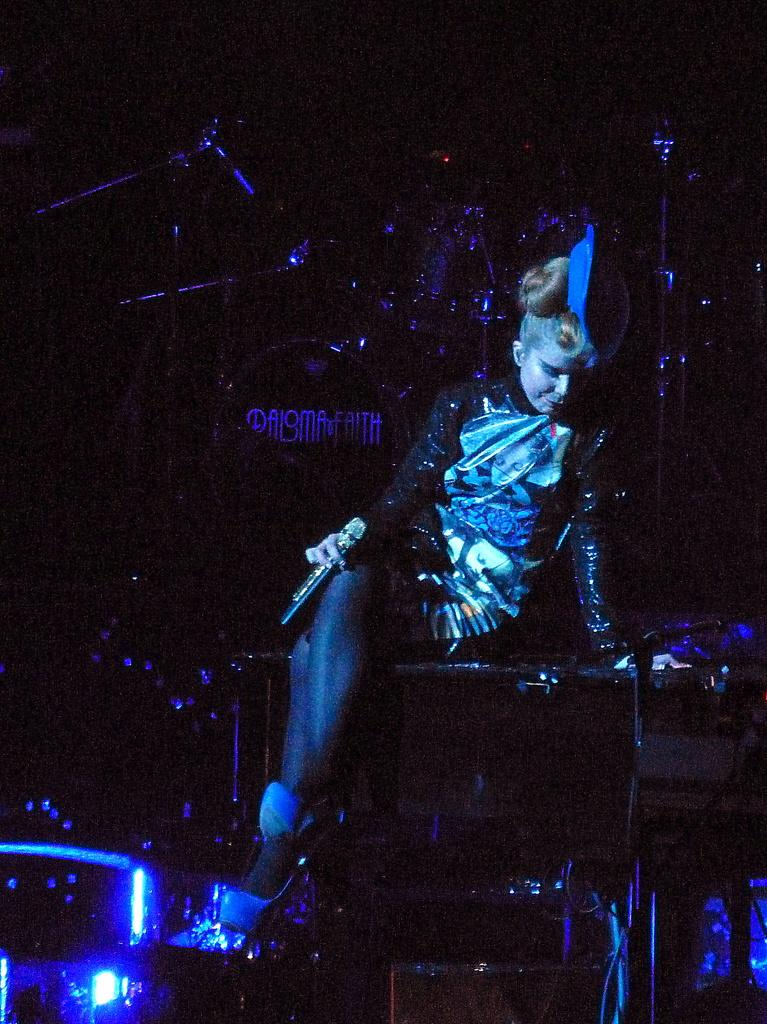What is the main subject of the image? The main subject of the image is a lady person. What is the lady person holding in the image? The lady person is holding a microphone. What is the lady person sitting on in the image? The lady person is sitting on something, but the specific object is not mentioned in the facts. What type of musical equipment can be seen in the image? There are drums and other musical instruments in the image. What type of coat is the lady person wearing in the image? There is no mention of a coat in the facts, so we cannot determine if the lady person is wearing a coat or not. Is there a church visible in the image? There is no mention of a church in the facts, so we cannot determine if a church is visible or not. 